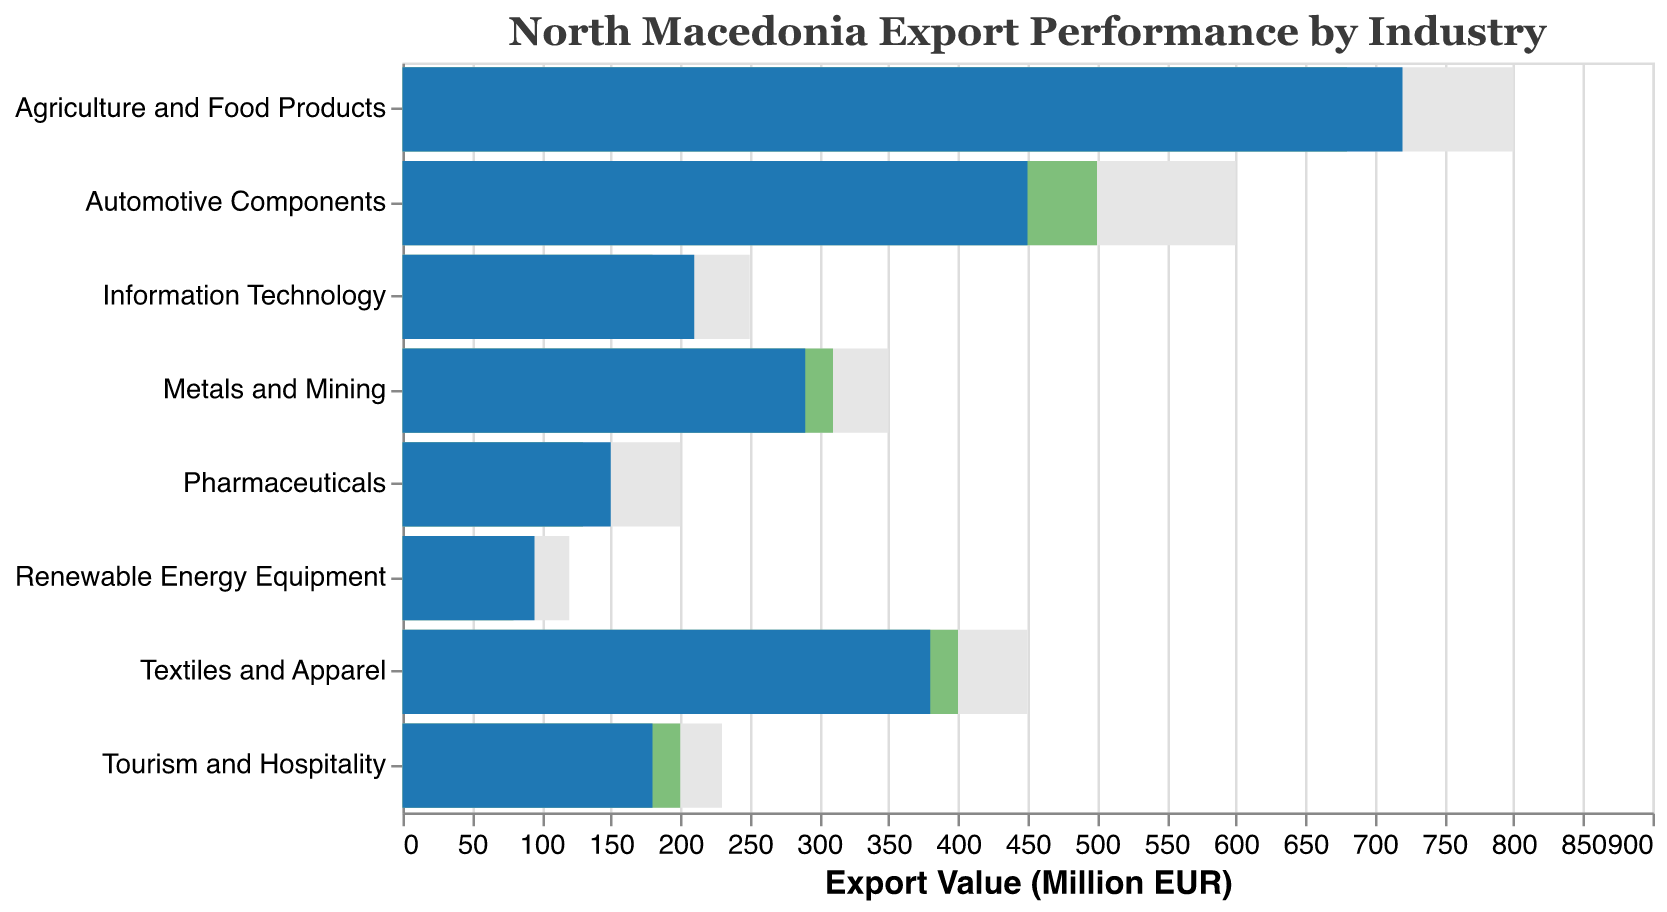What is the title of the figure? The title of the figure is displayed at the top of the chart, usually in a larger or distinct font to make it easily noticeable.
Answer: North Macedonia Export Performance by Industry What is the color used to represent the "Projected Export" bar? The "Projected Export" bar can be identified by its unique color, which stands out in the legend and the bars themselves.
Answer: Green Which industry has the highest actual export value? By observing the lengths of the blue bars representing actual export values, the industry with the longest bar has the highest value.
Answer: Agriculture and Food Products Which industry has the lowest projected export value? Observing the green bars that represent projected exports, the shortest green bar indicates the lowest projected export value.
Answer: Renewable Energy Equipment How far did "Automotive Components" fall short of its projected export? Subtract the actual export value from the projected export value for Automotive Components.
Answer: 50 What is the difference between the actual and projected export values for "Pharmaceuticals"? Subtract the projected export value from the actual export value for Pharmaceuticals.
Answer: 20 Which industries met or exceeded their projected export values? Compare the actual export bars (blue) with their respective projected export bars (green); if the blue bar is equal to or longer than the green bar, the industry met or exceeded its target.
Answer: Agriculture and Food Products, Information Technology, Pharmaceuticals How much higher is the "Comparison Measure" for "Textiles and Apparel" than its actual export? Subtract the actual export value from the comparison measure for Textiles and Apparel.
Answer: 70 Rank the industries by actual export value from highest to lowest. Observe and list the industries based on the decreasing order of the actual export bar lengths.
Answer: Agriculture and Food Products, Automotive Components, Textiles and Apparel, Metals and Mining, Information Technology, Tourism and Hospitality, Pharmaceuticals, Renewable Energy Equipment Which industries fall short of their comparison measure by more than 100 units? Subtract the actual export value from the comparison measure value for each industry and list the ones with a difference over 100 units.
Answer: Automotive Components, Agriculture and Food Products, Textiles and Apparel 